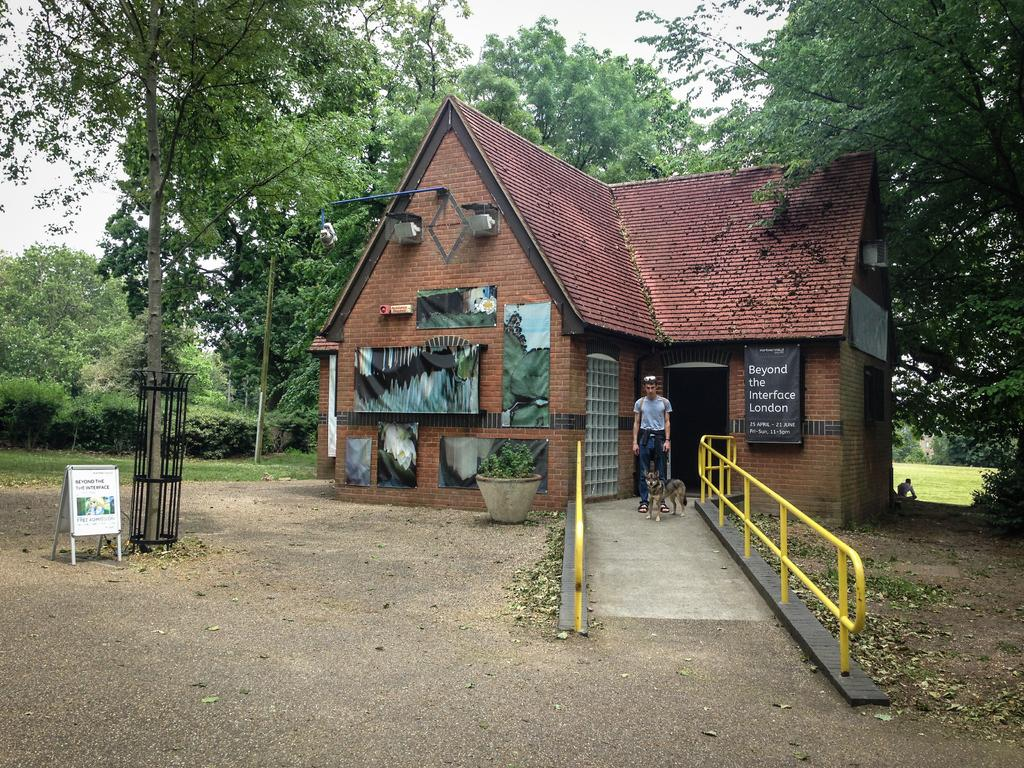<image>
Write a terse but informative summary of the picture. A sign outside the house states admission is free. 